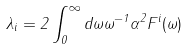Convert formula to latex. <formula><loc_0><loc_0><loc_500><loc_500>\lambda _ { i } = 2 \int _ { 0 } ^ { \infty } d \omega \omega ^ { - 1 } \alpha ^ { 2 } F ^ { i } ( \omega )</formula> 